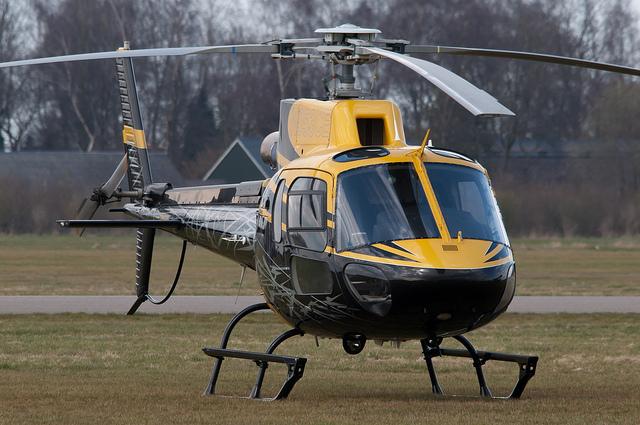Is the helicopter in the air?
Quick response, please. No. What colors are the helicopter?
Short answer required. Black and yellow. How many tiger stripes are on the nose of the helicopter?
Quick response, please. 4. 